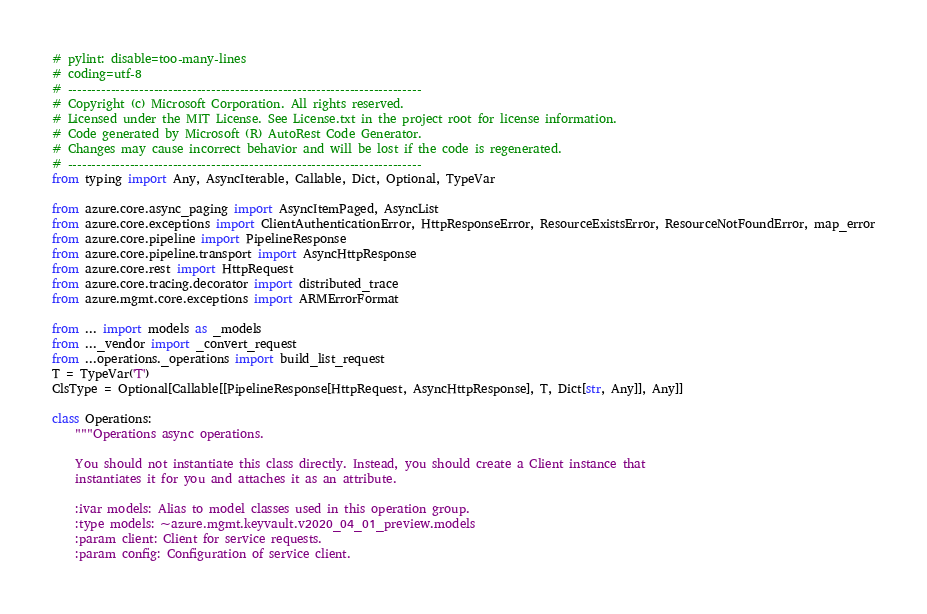<code> <loc_0><loc_0><loc_500><loc_500><_Python_># pylint: disable=too-many-lines
# coding=utf-8
# --------------------------------------------------------------------------
# Copyright (c) Microsoft Corporation. All rights reserved.
# Licensed under the MIT License. See License.txt in the project root for license information.
# Code generated by Microsoft (R) AutoRest Code Generator.
# Changes may cause incorrect behavior and will be lost if the code is regenerated.
# --------------------------------------------------------------------------
from typing import Any, AsyncIterable, Callable, Dict, Optional, TypeVar

from azure.core.async_paging import AsyncItemPaged, AsyncList
from azure.core.exceptions import ClientAuthenticationError, HttpResponseError, ResourceExistsError, ResourceNotFoundError, map_error
from azure.core.pipeline import PipelineResponse
from azure.core.pipeline.transport import AsyncHttpResponse
from azure.core.rest import HttpRequest
from azure.core.tracing.decorator import distributed_trace
from azure.mgmt.core.exceptions import ARMErrorFormat

from ... import models as _models
from ..._vendor import _convert_request
from ...operations._operations import build_list_request
T = TypeVar('T')
ClsType = Optional[Callable[[PipelineResponse[HttpRequest, AsyncHttpResponse], T, Dict[str, Any]], Any]]

class Operations:
    """Operations async operations.

    You should not instantiate this class directly. Instead, you should create a Client instance that
    instantiates it for you and attaches it as an attribute.

    :ivar models: Alias to model classes used in this operation group.
    :type models: ~azure.mgmt.keyvault.v2020_04_01_preview.models
    :param client: Client for service requests.
    :param config: Configuration of service client.</code> 